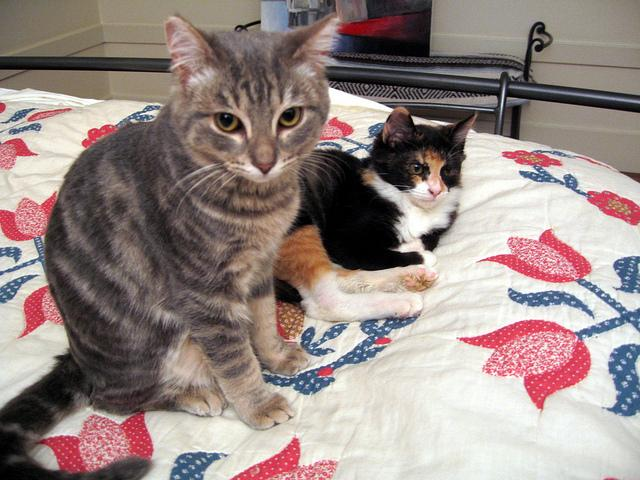What is the difference of these two cats? color 